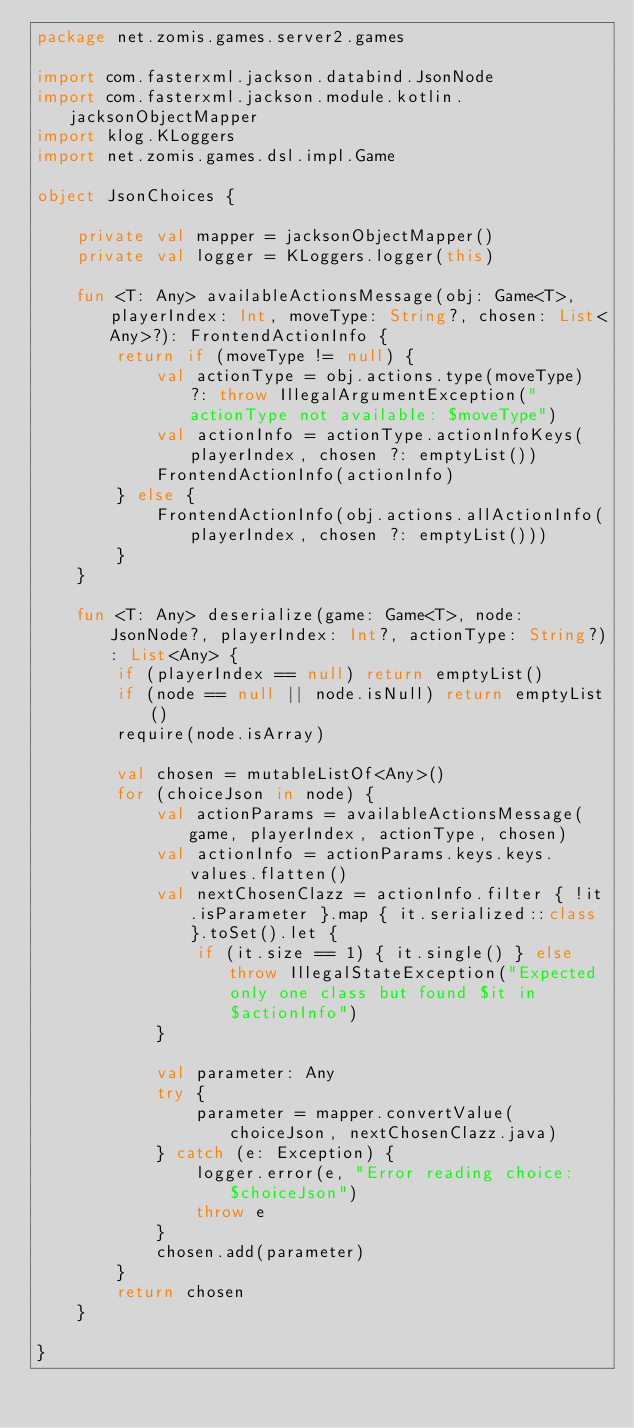Convert code to text. <code><loc_0><loc_0><loc_500><loc_500><_Kotlin_>package net.zomis.games.server2.games

import com.fasterxml.jackson.databind.JsonNode
import com.fasterxml.jackson.module.kotlin.jacksonObjectMapper
import klog.KLoggers
import net.zomis.games.dsl.impl.Game

object JsonChoices {

    private val mapper = jacksonObjectMapper()
    private val logger = KLoggers.logger(this)

    fun <T: Any> availableActionsMessage(obj: Game<T>, playerIndex: Int, moveType: String?, chosen: List<Any>?): FrontendActionInfo {
        return if (moveType != null) {
            val actionType = obj.actions.type(moveType) ?: throw IllegalArgumentException("actionType not available: $moveType")
            val actionInfo = actionType.actionInfoKeys(playerIndex, chosen ?: emptyList())
            FrontendActionInfo(actionInfo)
        } else {
            FrontendActionInfo(obj.actions.allActionInfo(playerIndex, chosen ?: emptyList()))
        }
    }

    fun <T: Any> deserialize(game: Game<T>, node: JsonNode?, playerIndex: Int?, actionType: String?): List<Any> {
        if (playerIndex == null) return emptyList()
        if (node == null || node.isNull) return emptyList()
        require(node.isArray)

        val chosen = mutableListOf<Any>()
        for (choiceJson in node) {
            val actionParams = availableActionsMessage(game, playerIndex, actionType, chosen)
            val actionInfo = actionParams.keys.keys.values.flatten()
            val nextChosenClazz = actionInfo.filter { !it.isParameter }.map { it.serialized::class }.toSet().let {
                if (it.size == 1) { it.single() } else throw IllegalStateException("Expected only one class but found $it in $actionInfo")
            }

            val parameter: Any
            try {
                parameter = mapper.convertValue(choiceJson, nextChosenClazz.java)
            } catch (e: Exception) {
                logger.error(e, "Error reading choice: $choiceJson")
                throw e
            }
            chosen.add(parameter)
        }
        return chosen
    }

}</code> 